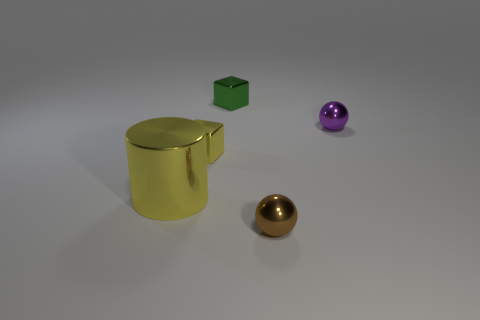What is the shape of the small yellow thing?
Your response must be concise. Cube. How many tiny objects have the same color as the big metallic thing?
Provide a short and direct response. 1. The tiny sphere in front of the small metallic ball behind the yellow metal object left of the tiny yellow metal object is made of what material?
Your response must be concise. Metal. What number of blue objects are cylinders or blocks?
Provide a succinct answer. 0. What size is the block that is in front of the metallic sphere that is on the right side of the tiny ball in front of the tiny purple metal ball?
Ensure brevity in your answer.  Small. What is the size of the brown shiny thing that is the same shape as the purple metallic thing?
Offer a terse response. Small. How many large things are green shiny blocks or yellow metallic objects?
Make the answer very short. 1. Do the object in front of the yellow metallic cylinder and the cube on the right side of the yellow cube have the same material?
Your answer should be very brief. Yes. There is a thing to the left of the yellow metal cube; what material is it?
Make the answer very short. Metal. How many metal things are either tiny brown spheres or green things?
Your answer should be compact. 2. 